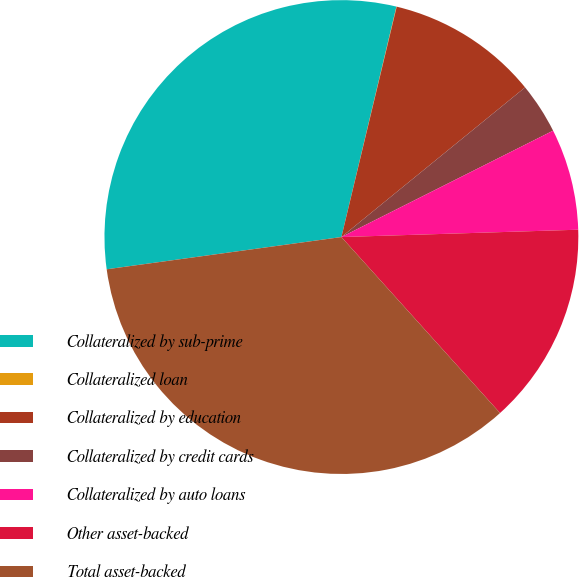Convert chart to OTSL. <chart><loc_0><loc_0><loc_500><loc_500><pie_chart><fcel>Collateralized by sub-prime<fcel>Collateralized loan<fcel>Collateralized by education<fcel>Collateralized by credit cards<fcel>Collateralized by auto loans<fcel>Other asset-backed<fcel>Total asset-backed<nl><fcel>30.91%<fcel>0.02%<fcel>10.37%<fcel>3.47%<fcel>6.92%<fcel>13.82%<fcel>34.51%<nl></chart> 